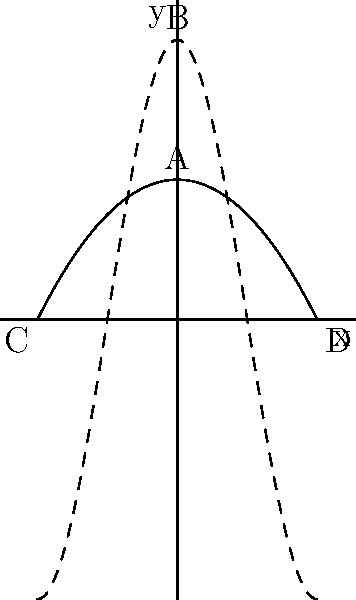In Botticelli's "The Birth of Venus," the curves representing the flowing hair of Venus and the undulating waves of the sea are reminiscent of which mathematical functions shown in the diagram above? To answer this question, let's analyze the curves in the diagram and relate them to the elements in Botticelli's "The Birth of Venus":

1. The solid curve in the diagram represents the function $f(x) = 1-x^2$, which is a parabola.
2. The dashed curve represents the function $g(x) = 2\cos(\pi x)$, which is a cosine function.

Now, let's consider the elements in Botticelli's painting:

3. Venus's flowing hair: The hair is depicted with graceful, undulating curves that create a sense of movement and fluidity.
4. The sea waves: The waves are represented with rolling, rhythmic patterns that suggest continuous motion.

Comparing these elements to the mathematical functions:

5. The parabola (solid curve) has a smooth, symmetrical shape but lacks the repetitive nature of waves or flowing hair.
6. The cosine function (dashed curve) exhibits a repeating, wave-like pattern that closely resembles both the flowing hair and the undulating sea waves in the painting.

Therefore, the cosine function (dashed curve) is more representative of the curves found in Botticelli's "The Birth of Venus." This choice of curve reflects the artist's use of rhythmic, harmonious lines to create a sense of beauty and natural flow in the composition.
Answer: Cosine function (dashed curve) 